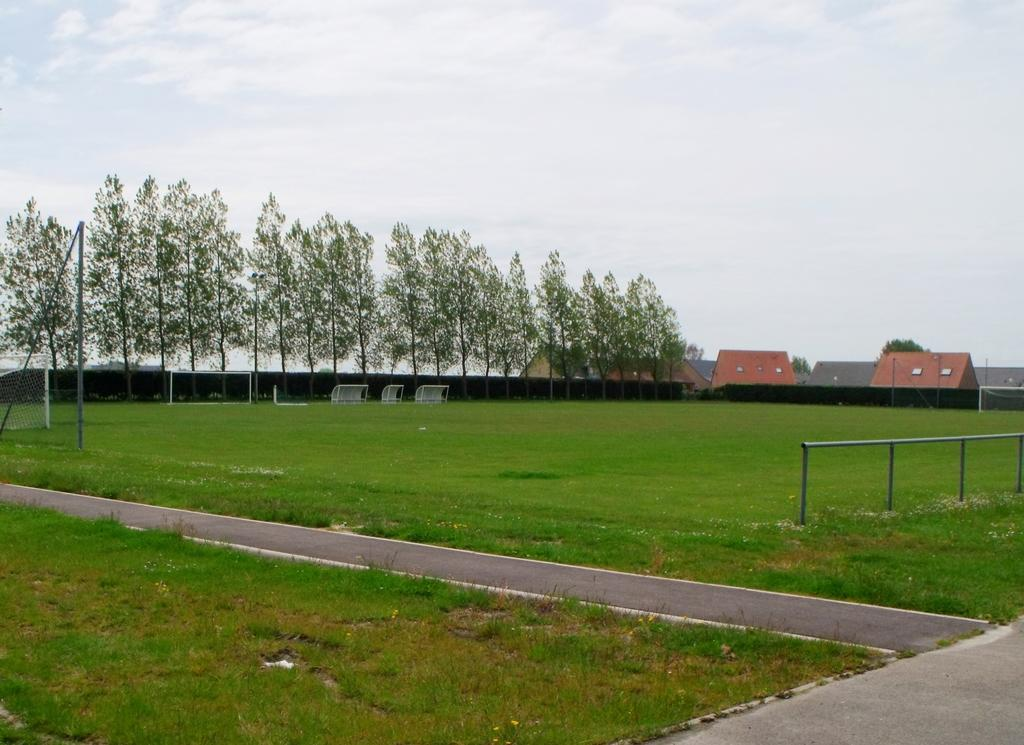What type of vegetation can be seen in the image? There is grass in the image. What sports-related feature is present in the image? There are goal posts in the image. What other natural elements can be seen in the image? There are trees in the image. What man-made structures are visible in the image? There are buildings in the image. What is visible in the background of the image? The sky is visible in the background of the image. How many cards are being played in the image? There are no cards present in the image; it features grass, goal posts, trees, buildings, and the sky. What type of motion is being performed by the trees in the image? The trees in the image are not performing any motion; they are stationary. 